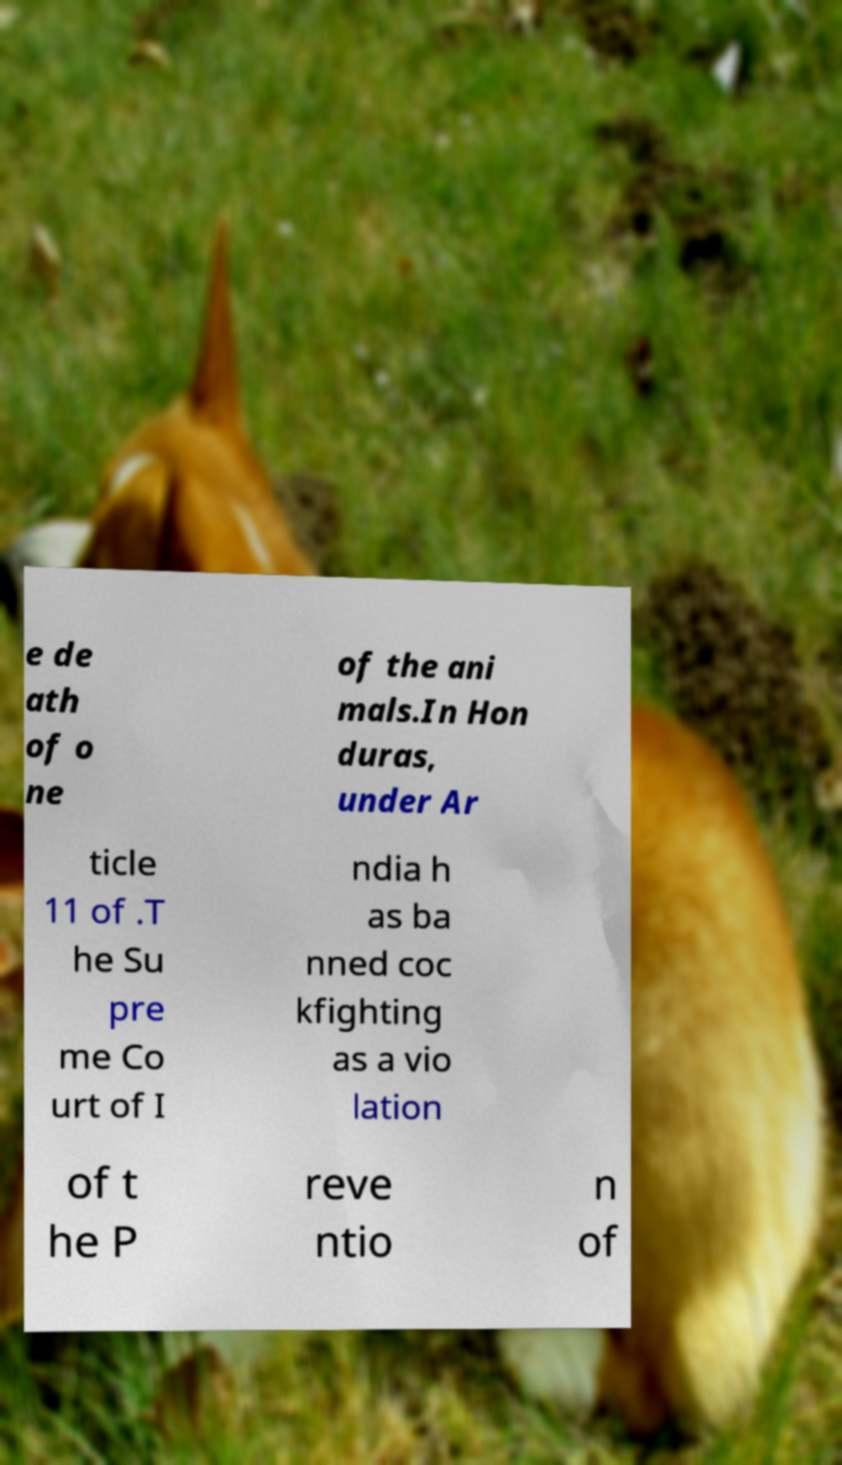Please read and relay the text visible in this image. What does it say? e de ath of o ne of the ani mals.In Hon duras, under Ar ticle 11 of .T he Su pre me Co urt of I ndia h as ba nned coc kfighting as a vio lation of t he P reve ntio n of 